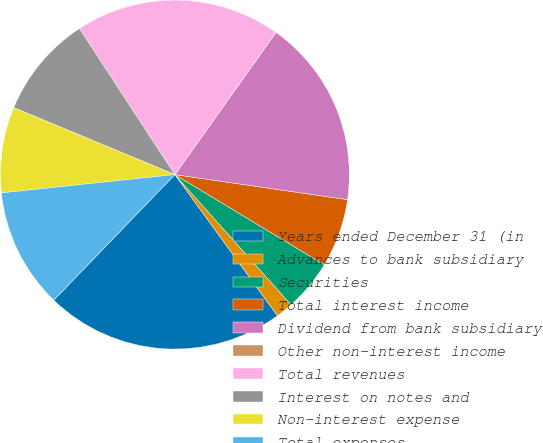Convert chart. <chart><loc_0><loc_0><loc_500><loc_500><pie_chart><fcel>Years ended December 31 (in<fcel>Advances to bank subsidiary<fcel>Securities<fcel>Total interest income<fcel>Dividend from bank subsidiary<fcel>Other non-interest income<fcel>Total revenues<fcel>Interest on notes and<fcel>Non-interest expense<fcel>Total expenses<nl><fcel>22.22%<fcel>1.59%<fcel>4.76%<fcel>6.35%<fcel>17.46%<fcel>0.0%<fcel>19.05%<fcel>9.52%<fcel>7.94%<fcel>11.11%<nl></chart> 